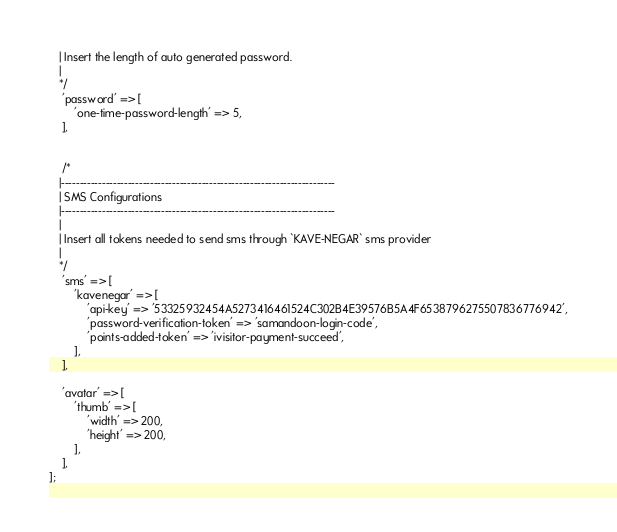Convert code to text. <code><loc_0><loc_0><loc_500><loc_500><_PHP_>   | Insert the length of auto generated password.
   |
   */
    'password' => [
        'one-time-password-length' => 5,
    ],


    /*
   |--------------------------------------------------------------------------
   | SMS Configurations
   |--------------------------------------------------------------------------
   |
   | Insert all tokens needed to send sms through `KAVE-NEGAR` sms provider
   |
   */
    'sms' => [
        'kavenegar' => [
            'api-key' => '53325932454A5273416461524C302B4E39576B5A4F6538796275507836776942',
            'password-verification-token' => 'samandoon-login-code',
            'points-added-token' => 'ivisitor-payment-succeed',
        ],
    ],

    'avatar' => [
        'thumb' => [
            'width' => 200,
            'height' => 200,
        ],
    ],
];
</code> 